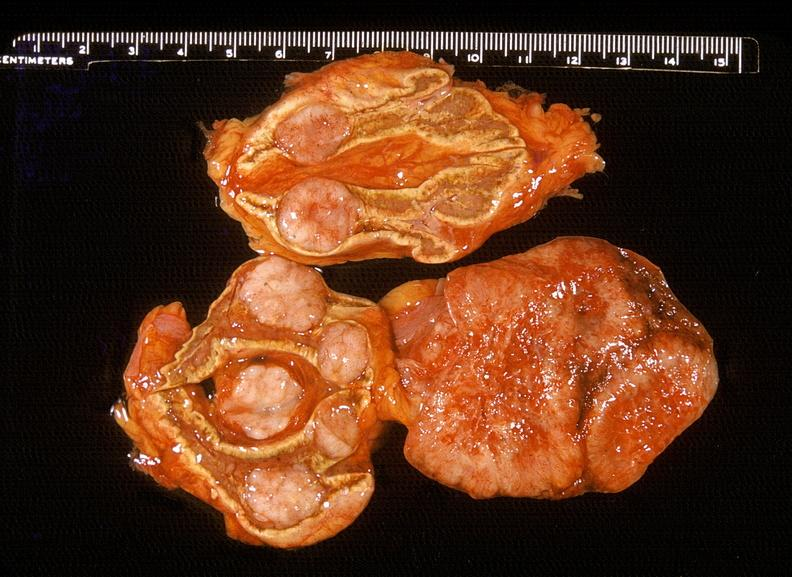s endocrine present?
Answer the question using a single word or phrase. Yes 